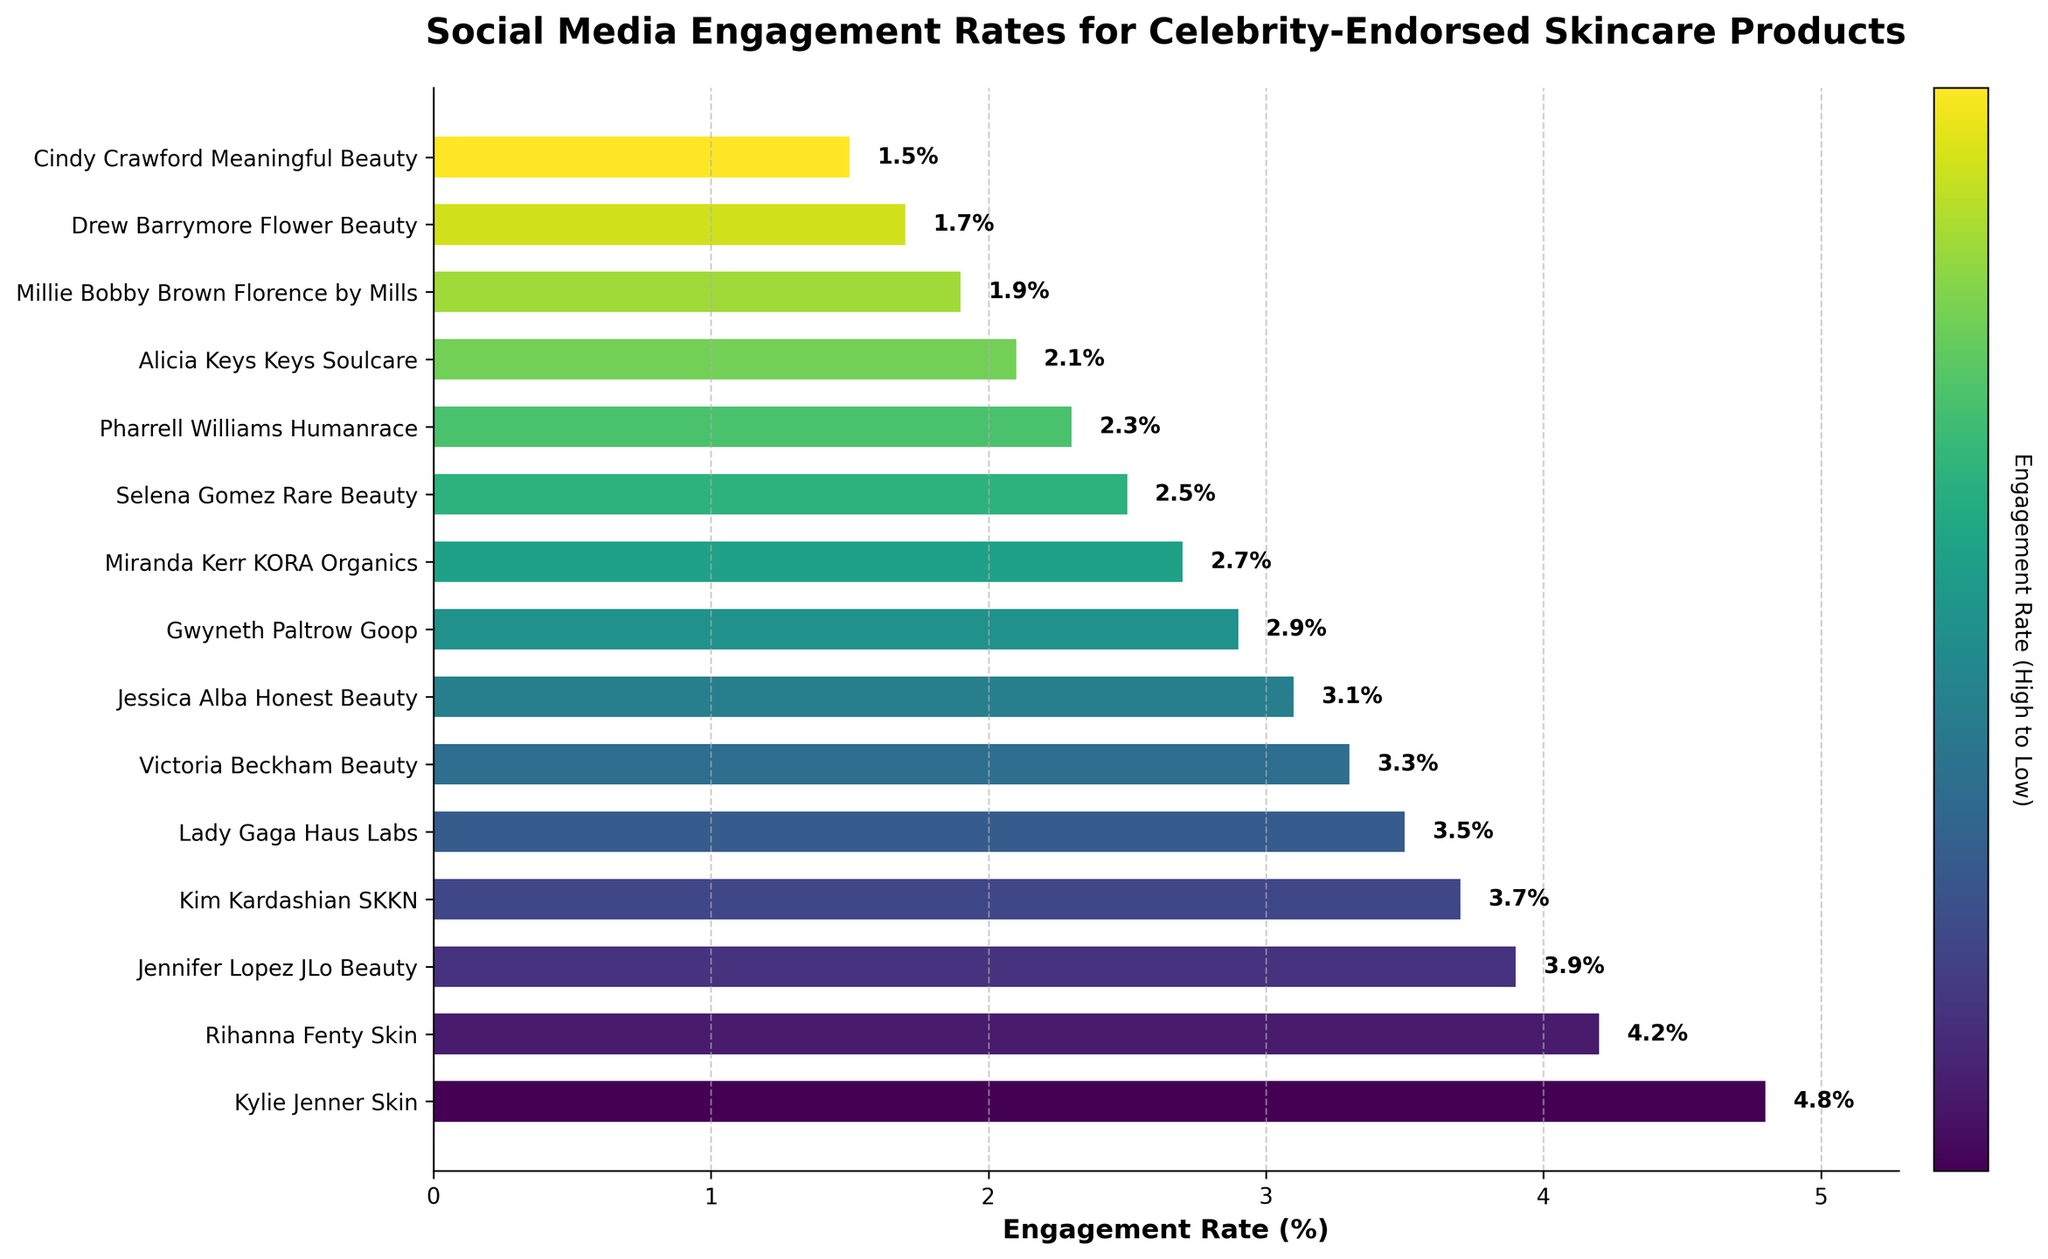Which celebrity-endorsed skincare product has the highest social media engagement rate? Looking at the chart, the bar corresponding to "Kylie Jenner Skin" is the longest, indicating it has the highest engagement rate.
Answer: Kylie Jenner Skin Which product has a lower engagement rate: "Alicia Keys Keys Soulcare" or "Millie Bobby Brown Florence by Mills"? Comparing the lengths of the bars for "Alicia Keys Keys Soulcare" and "Millie Bobby Brown Florence by Mills," the bar for "Alicia Keys Keys Soulcare" is shorter.
Answer: Alicia Keys Keys Soulcare How many products have an engagement rate above 4%? From the chart, the products above 4% are "Kylie Jenner Skin" and "Rihanna Fenty Skin." Thus, there are 2 products.
Answer: 2 What's the difference in engagement rate between the products with the highest and lowest engagement rates? The highest engagement rate is 4.8% (Kylie Jenner Skin) and the lowest is 1.5% (Cindy Crawford Meaningful Beauty). The difference is 4.8% - 1.5%.
Answer: 3.3% Which product has an engagement rate closest to the average engagement rate of all products shown? First calculate the average of all engagement rates: (4.8 + 4.2 + 3.9 + 3.7 + 3.5 + 3.3 + 3.1 + 2.9 + 2.7 + 2.5 + 2.3 + 2.1 + 1.9 + 1.7 + 1.5) / 15. The average is 3.0%. The product closest to this rate visually is "Gwyneth Paltrow Goop" (2.9%).
Answer: Gwyneth Paltrow Goop Which two products have a combined engagement rate of exactly 5.6%? Look for pairs of bars that together add up to 5.6%. "Victoria Beckham Beauty" (3.3%) and "Selena Gomez Rare Beauty" (2.5%) combined equal 5.8%, but "Pharrell Williams Humanrace" (2.3%) and "Jennifer Lopez JLo Beauty" (3.9%) combined equal 6.2%. Finding exact pairs visually, "Kim Kardashian SKKN" (3.7%) and "Jessica Alba Honest Beauty" (3.1%) combine to 5.8%, which is closer. Further checking shows no exact 5.6% pair.
Answer: None What is the median engagement rate among the products? Arrange the engagement rates in order: 1.5, 1.7, 1.9, 2.1, 2.3, 2.5, 2.7, 2.9, 3.1, 3.3, 3.5, 3.7, 3.9, 4.2, 4.8. With 15 values, the median is the 8th value (2.9).
Answer: 2.9% Which product has the third highest engagement rate? From the ordered list of engagement rates, the third highest is "Jennifer Lopez JLo Beauty" (3.9%).
Answer: Jennifer Lopez JLo Beauty Which celebrity-endorsed product has the shortest bar in the chart? The shortest bar belongs to "Cindy Crawford Meaningful Beauty" indicating the lowest engagement rate of 1.5%.
Answer: Cindy Crawford Meaningful Beauty If you combine the engagement rates of "Lady Gaga Haus Labs" and "Kim Kardashian SKKN," what is the total? The engagement rate of "Lady Gaga Haus Labs" is 3.5% and "Kim Kardashian SKKN" is 3.7%. Adding these gives 3.5% + 3.7%.
Answer: 7.2% 